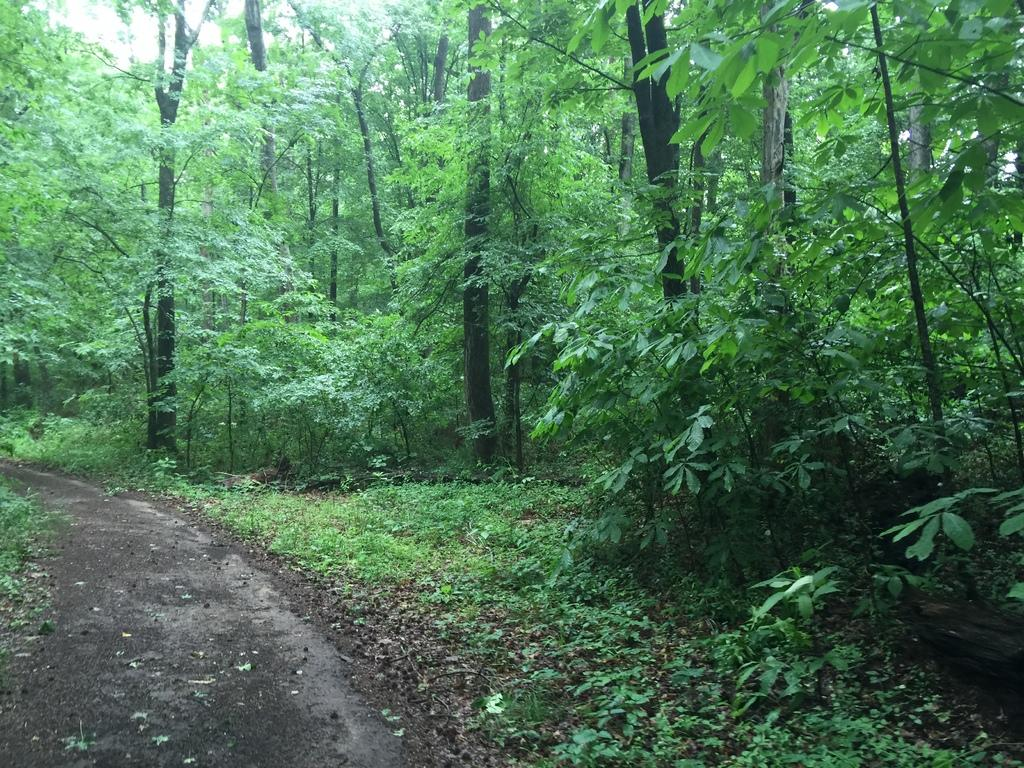What is the main feature in the center of the image? There is a road in the center of the image. What can be seen in the background of the image? There are trees in the background of the image. What type of vegetation is present at the bottom of the image? There is grass on the surface at the bottom of the image. What type of finger can be seen pointing at the trees in the image? There are no fingers present in the image; it only features a road, trees, and grass. 